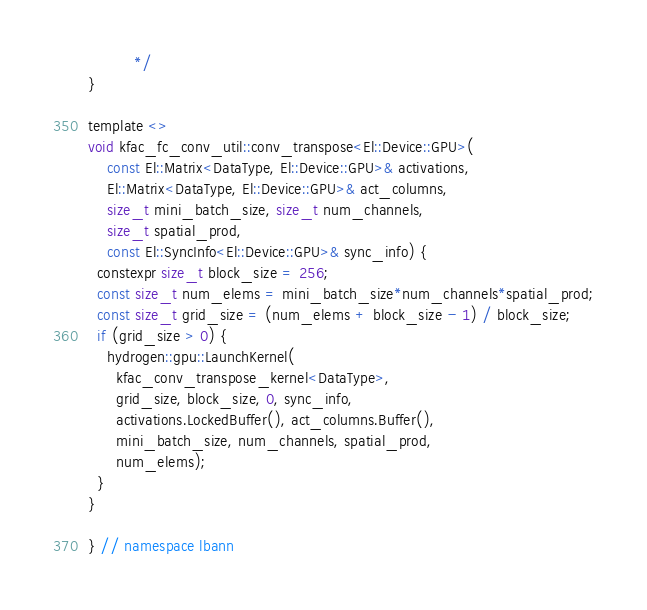Convert code to text. <code><loc_0><loc_0><loc_500><loc_500><_Cuda_>          */
}

template <>
void kfac_fc_conv_util::conv_transpose<El::Device::GPU>(
    const El::Matrix<DataType, El::Device::GPU>& activations,
    El::Matrix<DataType, El::Device::GPU>& act_columns,
    size_t mini_batch_size, size_t num_channels,
    size_t spatial_prod,
    const El::SyncInfo<El::Device::GPU>& sync_info) {
  constexpr size_t block_size = 256;
  const size_t num_elems = mini_batch_size*num_channels*spatial_prod;
  const size_t grid_size = (num_elems + block_size - 1) / block_size;
  if (grid_size > 0) {
    hydrogen::gpu::LaunchKernel(
      kfac_conv_transpose_kernel<DataType>,
      grid_size, block_size, 0, sync_info,
      activations.LockedBuffer(), act_columns.Buffer(),
      mini_batch_size, num_channels, spatial_prod,
      num_elems);
  }
}

} // namespace lbann
</code> 